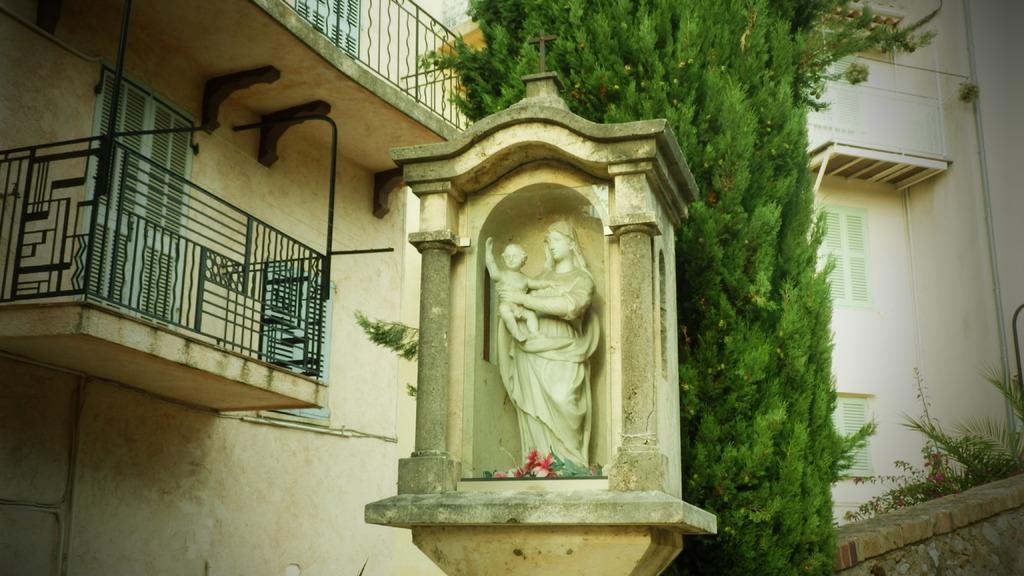In one or two sentences, can you explain what this image depicts? This image consists of a sculpture. At the bottom of the sculpture, there are flowers. On the left, there is a building along with the balcony. In the background, there is a tree. On the right, there is another building. At the bottom, there are plants and a wall. 